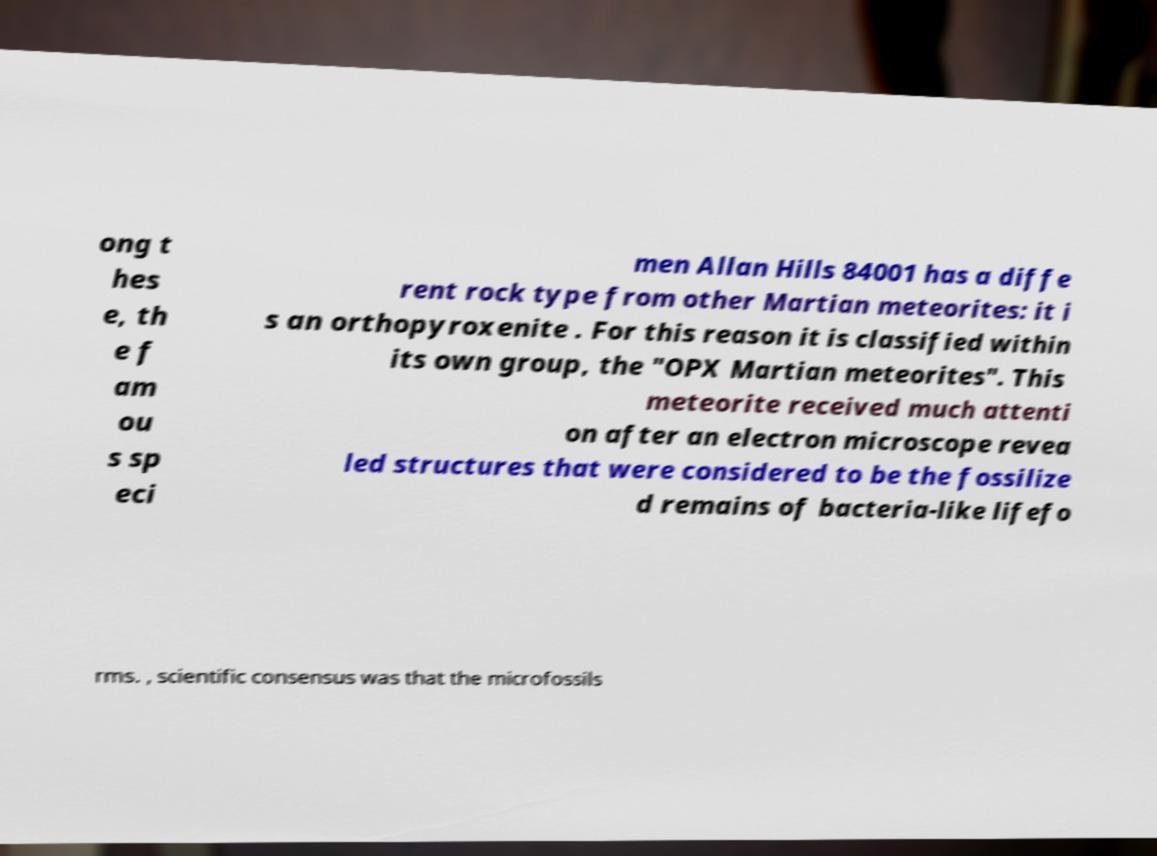Can you read and provide the text displayed in the image?This photo seems to have some interesting text. Can you extract and type it out for me? ong t hes e, th e f am ou s sp eci men Allan Hills 84001 has a diffe rent rock type from other Martian meteorites: it i s an orthopyroxenite . For this reason it is classified within its own group, the "OPX Martian meteorites". This meteorite received much attenti on after an electron microscope revea led structures that were considered to be the fossilize d remains of bacteria-like lifefo rms. , scientific consensus was that the microfossils 